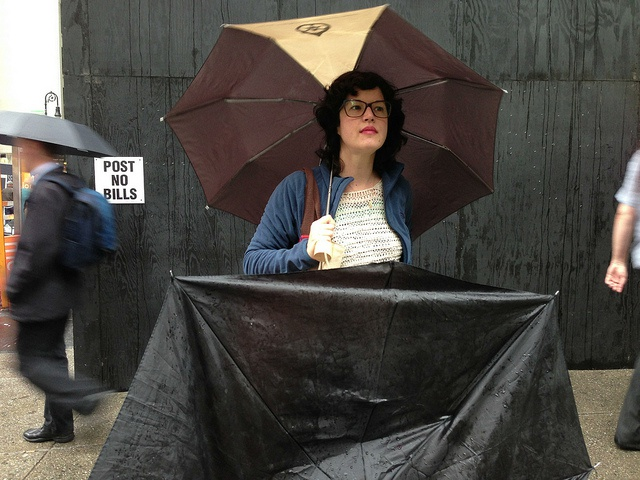Describe the objects in this image and their specific colors. I can see umbrella in white, black, and gray tones, umbrella in white, maroon, black, tan, and gray tones, people in white, black, ivory, and gray tones, people in white, black, and gray tones, and people in white, black, gray, lightgray, and tan tones in this image. 